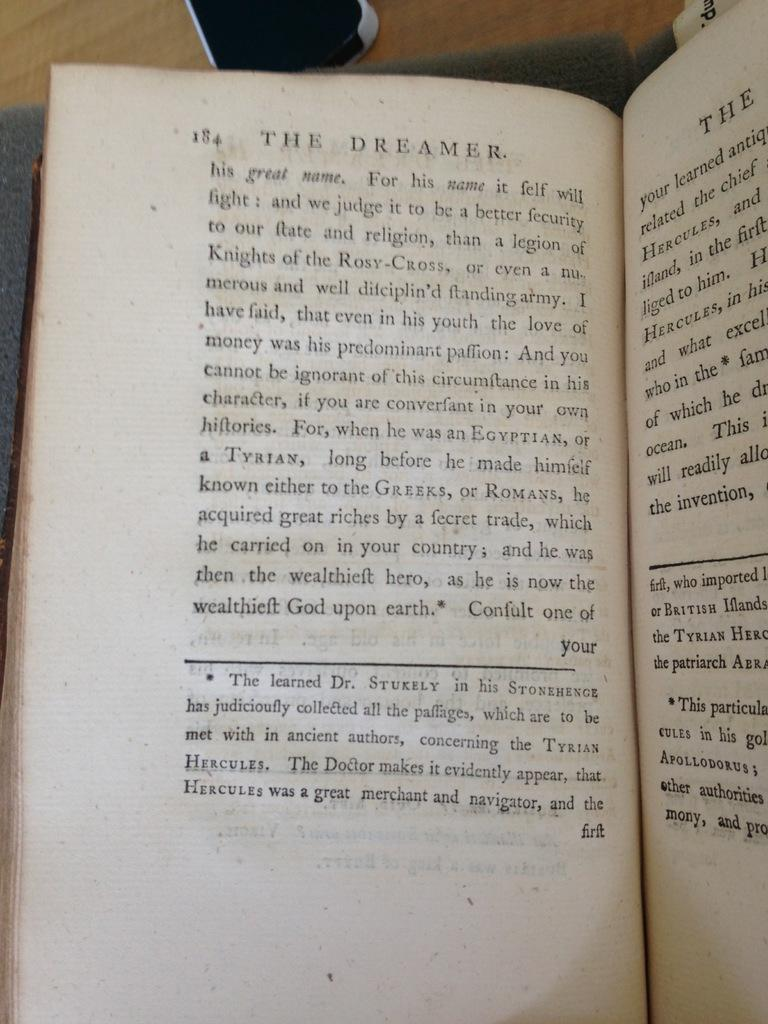<image>
Present a compact description of the photo's key features. The book shown is opened to page 184. 